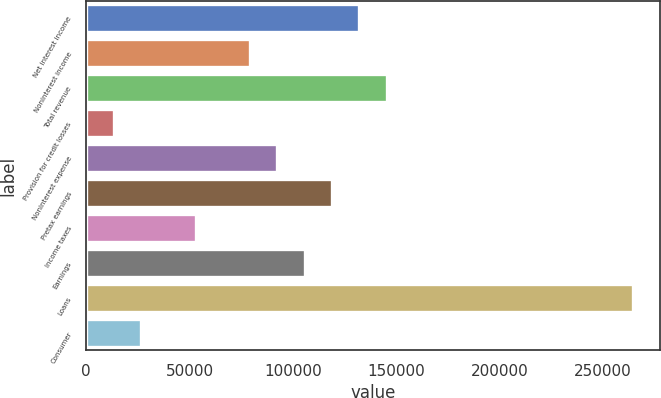Convert chart. <chart><loc_0><loc_0><loc_500><loc_500><bar_chart><fcel>Net interest income<fcel>Noninterest income<fcel>Total revenue<fcel>Provision for credit losses<fcel>Noninterest expense<fcel>Pretax earnings<fcel>Income taxes<fcel>Earnings<fcel>Loans<fcel>Consumer<nl><fcel>132161<fcel>79333.8<fcel>145368<fcel>13299.8<fcel>92540.6<fcel>118954<fcel>52920.2<fcel>105747<fcel>264229<fcel>26506.6<nl></chart> 